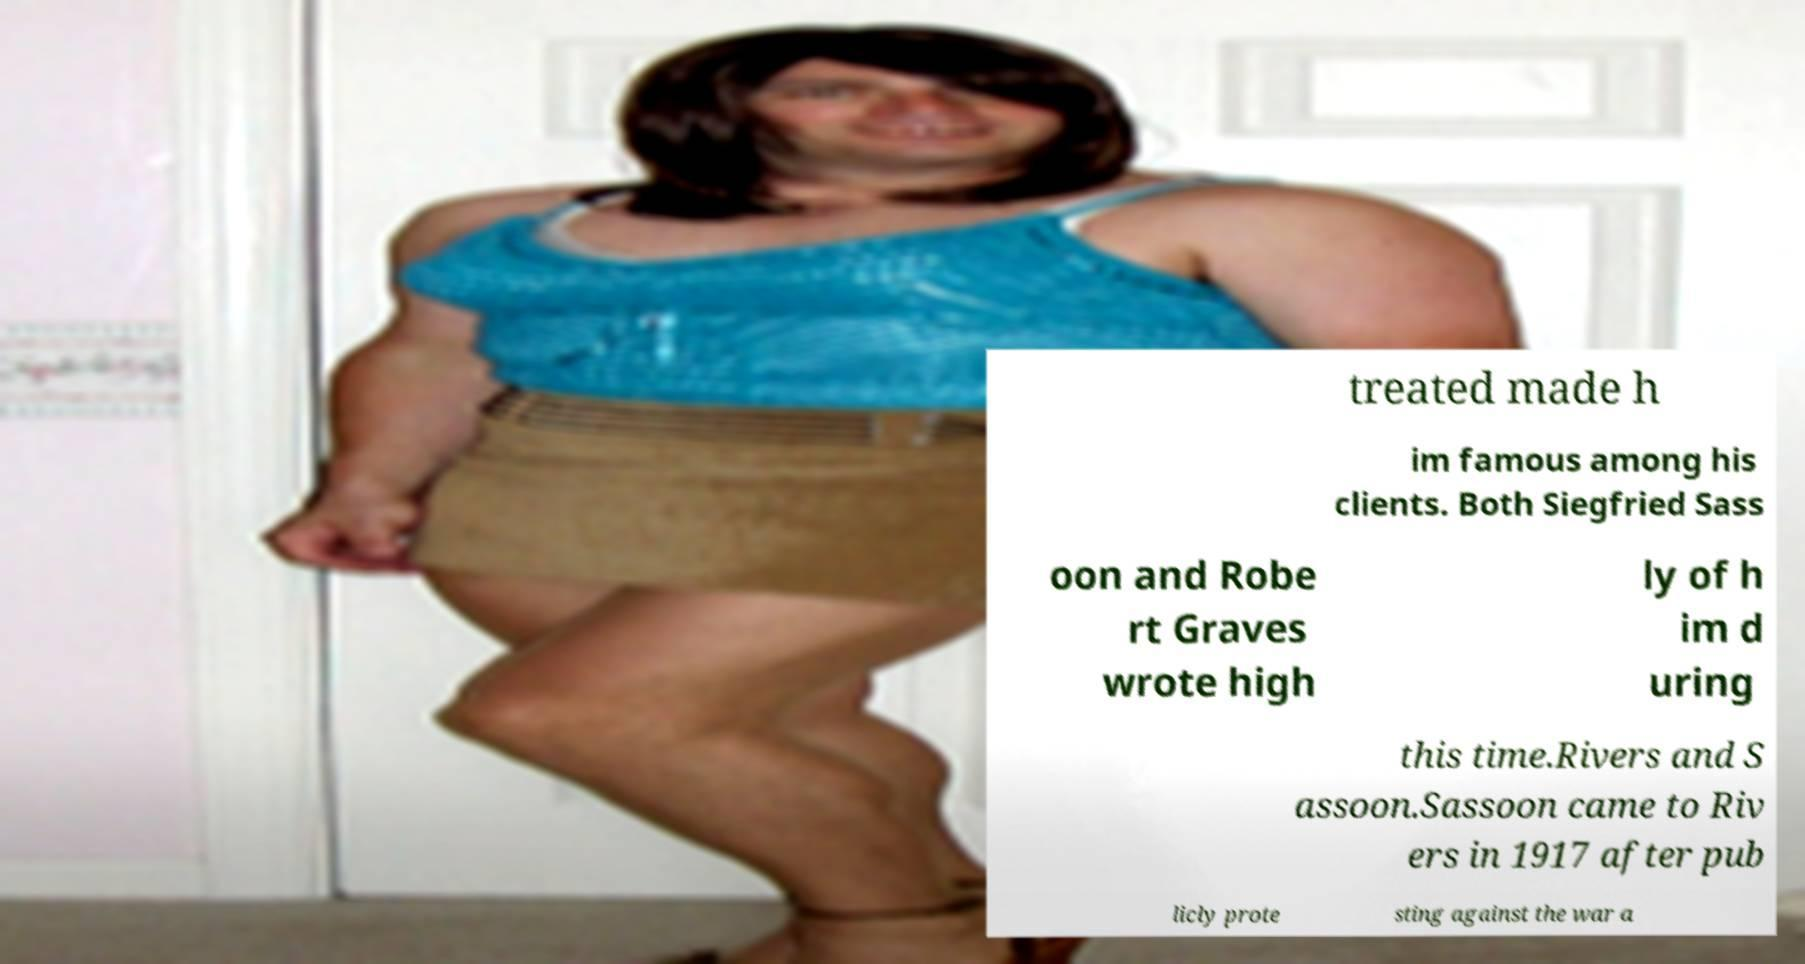Please read and relay the text visible in this image. What does it say? treated made h im famous among his clients. Both Siegfried Sass oon and Robe rt Graves wrote high ly of h im d uring this time.Rivers and S assoon.Sassoon came to Riv ers in 1917 after pub licly prote sting against the war a 